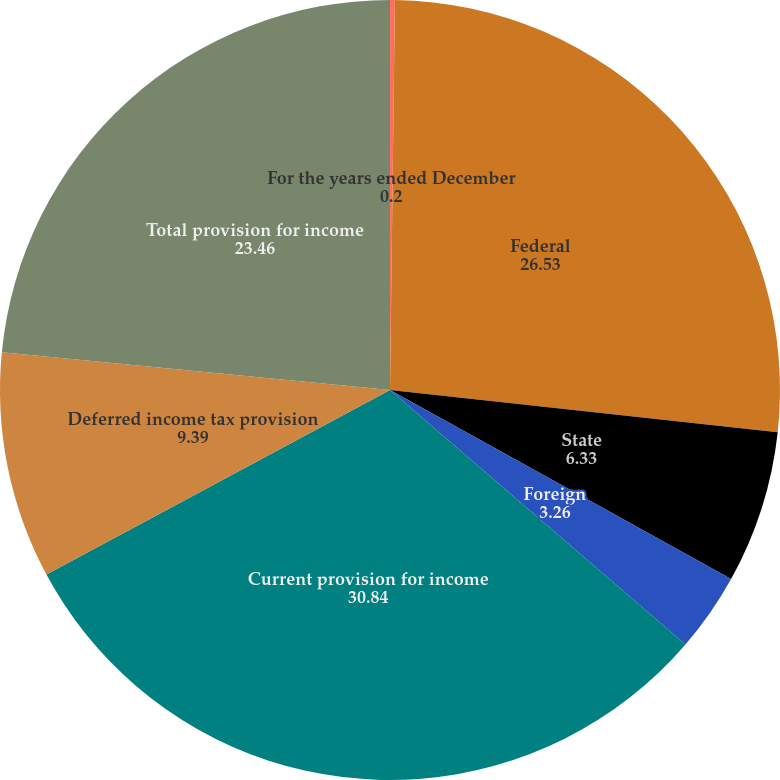Convert chart. <chart><loc_0><loc_0><loc_500><loc_500><pie_chart><fcel>For the years ended December<fcel>Federal<fcel>State<fcel>Foreign<fcel>Current provision for income<fcel>Deferred income tax provision<fcel>Total provision for income<nl><fcel>0.2%<fcel>26.53%<fcel>6.33%<fcel>3.26%<fcel>30.84%<fcel>9.39%<fcel>23.46%<nl></chart> 